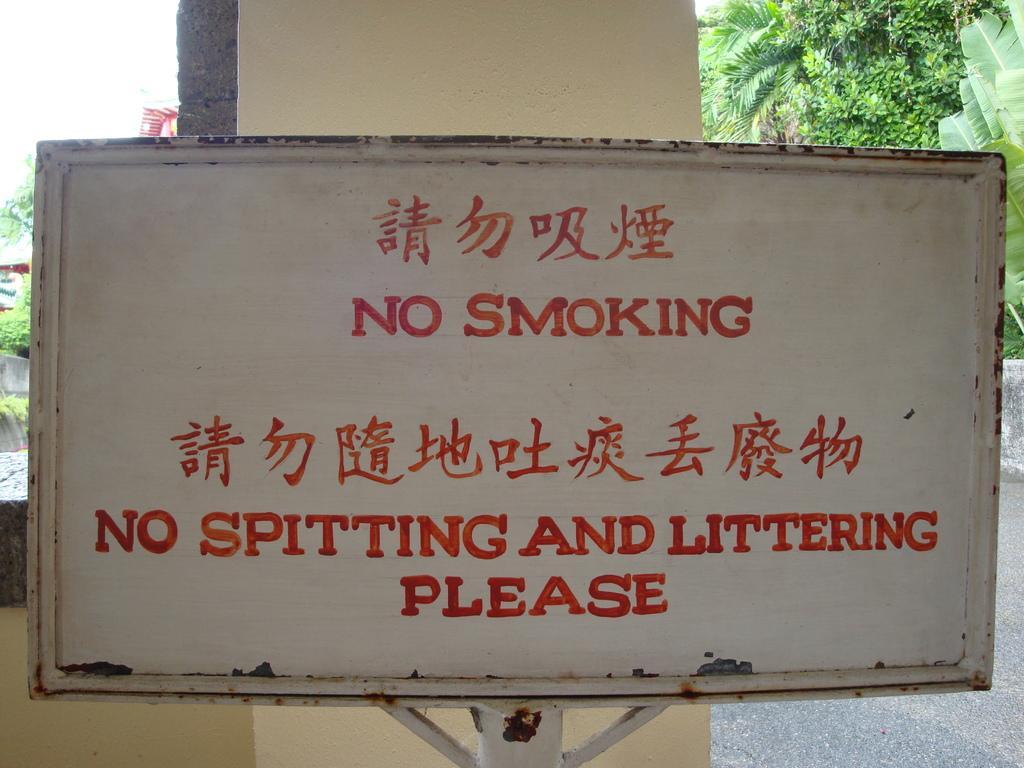Can you describe this image briefly? In this picture there is a white board which has no smoking and something written on it in red color and there is a wall and trees in the background. 